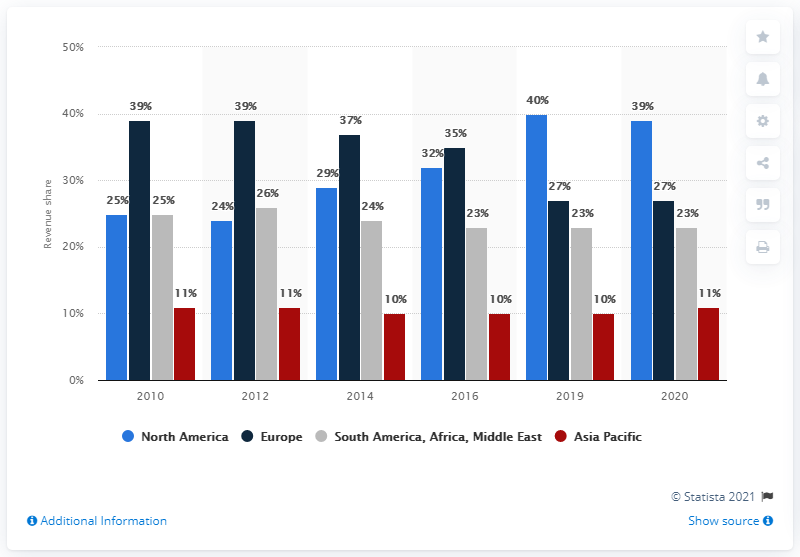Draw attention to some important aspects in this diagram. In 2020, BASF's Agricultural Solutions segment generated approximately 27% of the company's total revenues. 